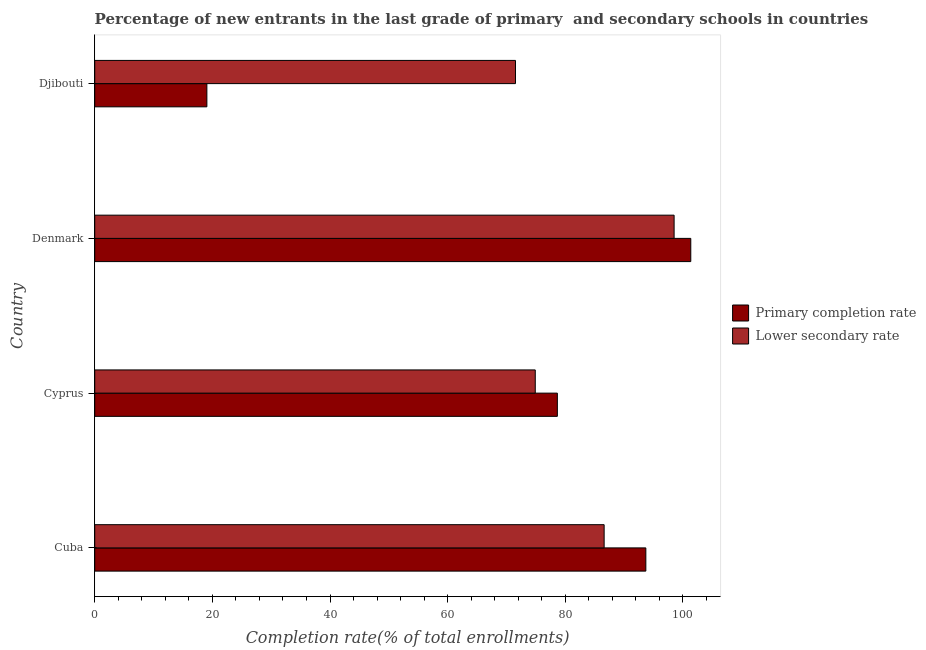How many different coloured bars are there?
Offer a terse response. 2. How many groups of bars are there?
Give a very brief answer. 4. Are the number of bars per tick equal to the number of legend labels?
Give a very brief answer. Yes. What is the label of the 4th group of bars from the top?
Your answer should be compact. Cuba. In how many cases, is the number of bars for a given country not equal to the number of legend labels?
Make the answer very short. 0. What is the completion rate in primary schools in Cuba?
Your answer should be compact. 93.69. Across all countries, what is the maximum completion rate in secondary schools?
Offer a terse response. 98.5. Across all countries, what is the minimum completion rate in primary schools?
Offer a very short reply. 19.07. In which country was the completion rate in secondary schools minimum?
Offer a terse response. Djibouti. What is the total completion rate in primary schools in the graph?
Provide a succinct answer. 292.75. What is the difference between the completion rate in secondary schools in Cuba and that in Djibouti?
Make the answer very short. 15.07. What is the difference between the completion rate in primary schools in Cuba and the completion rate in secondary schools in Djibouti?
Make the answer very short. 22.16. What is the average completion rate in primary schools per country?
Make the answer very short. 73.19. What is the difference between the completion rate in secondary schools and completion rate in primary schools in Cyprus?
Provide a succinct answer. -3.76. In how many countries, is the completion rate in primary schools greater than 68 %?
Provide a succinct answer. 3. What is the ratio of the completion rate in secondary schools in Cuba to that in Djibouti?
Your answer should be compact. 1.21. Is the completion rate in secondary schools in Cuba less than that in Cyprus?
Offer a terse response. No. What is the difference between the highest and the second highest completion rate in primary schools?
Provide a short and direct response. 7.64. What is the difference between the highest and the lowest completion rate in secondary schools?
Ensure brevity in your answer.  26.97. What does the 1st bar from the top in Djibouti represents?
Your response must be concise. Lower secondary rate. What does the 2nd bar from the bottom in Cyprus represents?
Your response must be concise. Lower secondary rate. How many bars are there?
Your answer should be compact. 8. How many countries are there in the graph?
Your answer should be compact. 4. What is the difference between two consecutive major ticks on the X-axis?
Ensure brevity in your answer.  20. Does the graph contain any zero values?
Provide a succinct answer. No. Does the graph contain grids?
Provide a short and direct response. No. How are the legend labels stacked?
Offer a very short reply. Vertical. What is the title of the graph?
Ensure brevity in your answer.  Percentage of new entrants in the last grade of primary  and secondary schools in countries. Does "Public funds" appear as one of the legend labels in the graph?
Your answer should be compact. No. What is the label or title of the X-axis?
Ensure brevity in your answer.  Completion rate(% of total enrollments). What is the Completion rate(% of total enrollments) in Primary completion rate in Cuba?
Your answer should be very brief. 93.69. What is the Completion rate(% of total enrollments) of Lower secondary rate in Cuba?
Make the answer very short. 86.6. What is the Completion rate(% of total enrollments) in Primary completion rate in Cyprus?
Give a very brief answer. 78.65. What is the Completion rate(% of total enrollments) of Lower secondary rate in Cyprus?
Keep it short and to the point. 74.9. What is the Completion rate(% of total enrollments) in Primary completion rate in Denmark?
Ensure brevity in your answer.  101.34. What is the Completion rate(% of total enrollments) of Lower secondary rate in Denmark?
Make the answer very short. 98.5. What is the Completion rate(% of total enrollments) in Primary completion rate in Djibouti?
Offer a terse response. 19.07. What is the Completion rate(% of total enrollments) in Lower secondary rate in Djibouti?
Ensure brevity in your answer.  71.53. Across all countries, what is the maximum Completion rate(% of total enrollments) of Primary completion rate?
Your response must be concise. 101.34. Across all countries, what is the maximum Completion rate(% of total enrollments) of Lower secondary rate?
Your response must be concise. 98.5. Across all countries, what is the minimum Completion rate(% of total enrollments) in Primary completion rate?
Ensure brevity in your answer.  19.07. Across all countries, what is the minimum Completion rate(% of total enrollments) of Lower secondary rate?
Provide a succinct answer. 71.53. What is the total Completion rate(% of total enrollments) in Primary completion rate in the graph?
Offer a terse response. 292.75. What is the total Completion rate(% of total enrollments) in Lower secondary rate in the graph?
Provide a short and direct response. 331.53. What is the difference between the Completion rate(% of total enrollments) of Primary completion rate in Cuba and that in Cyprus?
Make the answer very short. 15.04. What is the difference between the Completion rate(% of total enrollments) of Lower secondary rate in Cuba and that in Cyprus?
Provide a short and direct response. 11.71. What is the difference between the Completion rate(% of total enrollments) of Primary completion rate in Cuba and that in Denmark?
Provide a succinct answer. -7.64. What is the difference between the Completion rate(% of total enrollments) of Lower secondary rate in Cuba and that in Denmark?
Make the answer very short. -11.9. What is the difference between the Completion rate(% of total enrollments) of Primary completion rate in Cuba and that in Djibouti?
Give a very brief answer. 74.63. What is the difference between the Completion rate(% of total enrollments) in Lower secondary rate in Cuba and that in Djibouti?
Give a very brief answer. 15.07. What is the difference between the Completion rate(% of total enrollments) in Primary completion rate in Cyprus and that in Denmark?
Offer a terse response. -22.68. What is the difference between the Completion rate(% of total enrollments) in Lower secondary rate in Cyprus and that in Denmark?
Your answer should be compact. -23.61. What is the difference between the Completion rate(% of total enrollments) of Primary completion rate in Cyprus and that in Djibouti?
Ensure brevity in your answer.  59.58. What is the difference between the Completion rate(% of total enrollments) of Lower secondary rate in Cyprus and that in Djibouti?
Ensure brevity in your answer.  3.36. What is the difference between the Completion rate(% of total enrollments) of Primary completion rate in Denmark and that in Djibouti?
Keep it short and to the point. 82.27. What is the difference between the Completion rate(% of total enrollments) of Lower secondary rate in Denmark and that in Djibouti?
Your answer should be compact. 26.97. What is the difference between the Completion rate(% of total enrollments) of Primary completion rate in Cuba and the Completion rate(% of total enrollments) of Lower secondary rate in Cyprus?
Your answer should be compact. 18.8. What is the difference between the Completion rate(% of total enrollments) in Primary completion rate in Cuba and the Completion rate(% of total enrollments) in Lower secondary rate in Denmark?
Keep it short and to the point. -4.81. What is the difference between the Completion rate(% of total enrollments) in Primary completion rate in Cuba and the Completion rate(% of total enrollments) in Lower secondary rate in Djibouti?
Your response must be concise. 22.16. What is the difference between the Completion rate(% of total enrollments) of Primary completion rate in Cyprus and the Completion rate(% of total enrollments) of Lower secondary rate in Denmark?
Provide a succinct answer. -19.85. What is the difference between the Completion rate(% of total enrollments) in Primary completion rate in Cyprus and the Completion rate(% of total enrollments) in Lower secondary rate in Djibouti?
Provide a short and direct response. 7.12. What is the difference between the Completion rate(% of total enrollments) in Primary completion rate in Denmark and the Completion rate(% of total enrollments) in Lower secondary rate in Djibouti?
Your answer should be compact. 29.8. What is the average Completion rate(% of total enrollments) in Primary completion rate per country?
Offer a terse response. 73.19. What is the average Completion rate(% of total enrollments) in Lower secondary rate per country?
Offer a very short reply. 82.88. What is the difference between the Completion rate(% of total enrollments) in Primary completion rate and Completion rate(% of total enrollments) in Lower secondary rate in Cuba?
Provide a succinct answer. 7.09. What is the difference between the Completion rate(% of total enrollments) in Primary completion rate and Completion rate(% of total enrollments) in Lower secondary rate in Cyprus?
Offer a terse response. 3.76. What is the difference between the Completion rate(% of total enrollments) in Primary completion rate and Completion rate(% of total enrollments) in Lower secondary rate in Denmark?
Give a very brief answer. 2.83. What is the difference between the Completion rate(% of total enrollments) of Primary completion rate and Completion rate(% of total enrollments) of Lower secondary rate in Djibouti?
Provide a succinct answer. -52.47. What is the ratio of the Completion rate(% of total enrollments) of Primary completion rate in Cuba to that in Cyprus?
Your response must be concise. 1.19. What is the ratio of the Completion rate(% of total enrollments) of Lower secondary rate in Cuba to that in Cyprus?
Your answer should be very brief. 1.16. What is the ratio of the Completion rate(% of total enrollments) of Primary completion rate in Cuba to that in Denmark?
Offer a very short reply. 0.92. What is the ratio of the Completion rate(% of total enrollments) of Lower secondary rate in Cuba to that in Denmark?
Your answer should be compact. 0.88. What is the ratio of the Completion rate(% of total enrollments) in Primary completion rate in Cuba to that in Djibouti?
Offer a terse response. 4.91. What is the ratio of the Completion rate(% of total enrollments) of Lower secondary rate in Cuba to that in Djibouti?
Your response must be concise. 1.21. What is the ratio of the Completion rate(% of total enrollments) of Primary completion rate in Cyprus to that in Denmark?
Your answer should be very brief. 0.78. What is the ratio of the Completion rate(% of total enrollments) of Lower secondary rate in Cyprus to that in Denmark?
Give a very brief answer. 0.76. What is the ratio of the Completion rate(% of total enrollments) of Primary completion rate in Cyprus to that in Djibouti?
Provide a succinct answer. 4.12. What is the ratio of the Completion rate(% of total enrollments) in Lower secondary rate in Cyprus to that in Djibouti?
Your response must be concise. 1.05. What is the ratio of the Completion rate(% of total enrollments) of Primary completion rate in Denmark to that in Djibouti?
Ensure brevity in your answer.  5.31. What is the ratio of the Completion rate(% of total enrollments) in Lower secondary rate in Denmark to that in Djibouti?
Provide a succinct answer. 1.38. What is the difference between the highest and the second highest Completion rate(% of total enrollments) of Primary completion rate?
Offer a terse response. 7.64. What is the difference between the highest and the second highest Completion rate(% of total enrollments) in Lower secondary rate?
Your answer should be compact. 11.9. What is the difference between the highest and the lowest Completion rate(% of total enrollments) of Primary completion rate?
Offer a terse response. 82.27. What is the difference between the highest and the lowest Completion rate(% of total enrollments) of Lower secondary rate?
Your response must be concise. 26.97. 